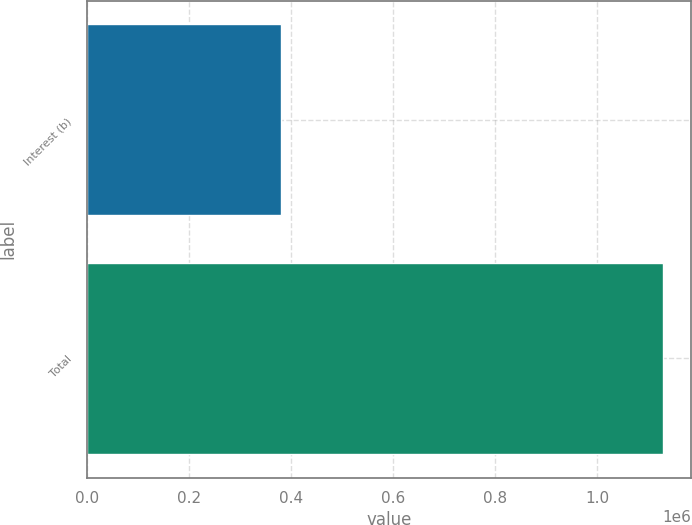<chart> <loc_0><loc_0><loc_500><loc_500><bar_chart><fcel>Interest (b)<fcel>Total<nl><fcel>381128<fcel>1.1285e+06<nl></chart> 